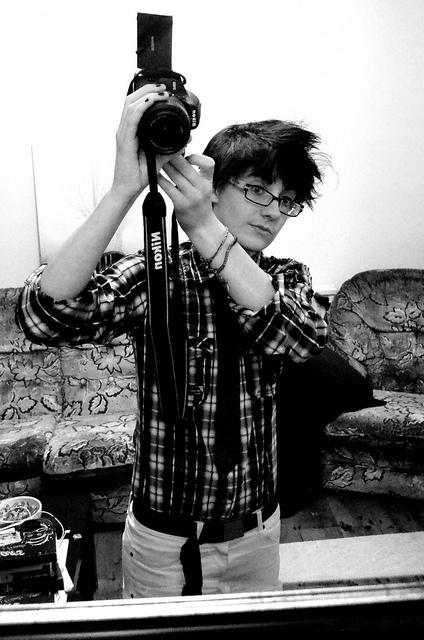Could the photo be considered a selfie?
Quick response, please. Yes. Is this person wearing glasses?
Quick response, please. Yes. Is he wearing a tie?
Quick response, please. Yes. 